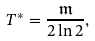Convert formula to latex. <formula><loc_0><loc_0><loc_500><loc_500>T ^ { * } = \frac { \mathfrak { m } } { 2 \ln 2 } ,</formula> 